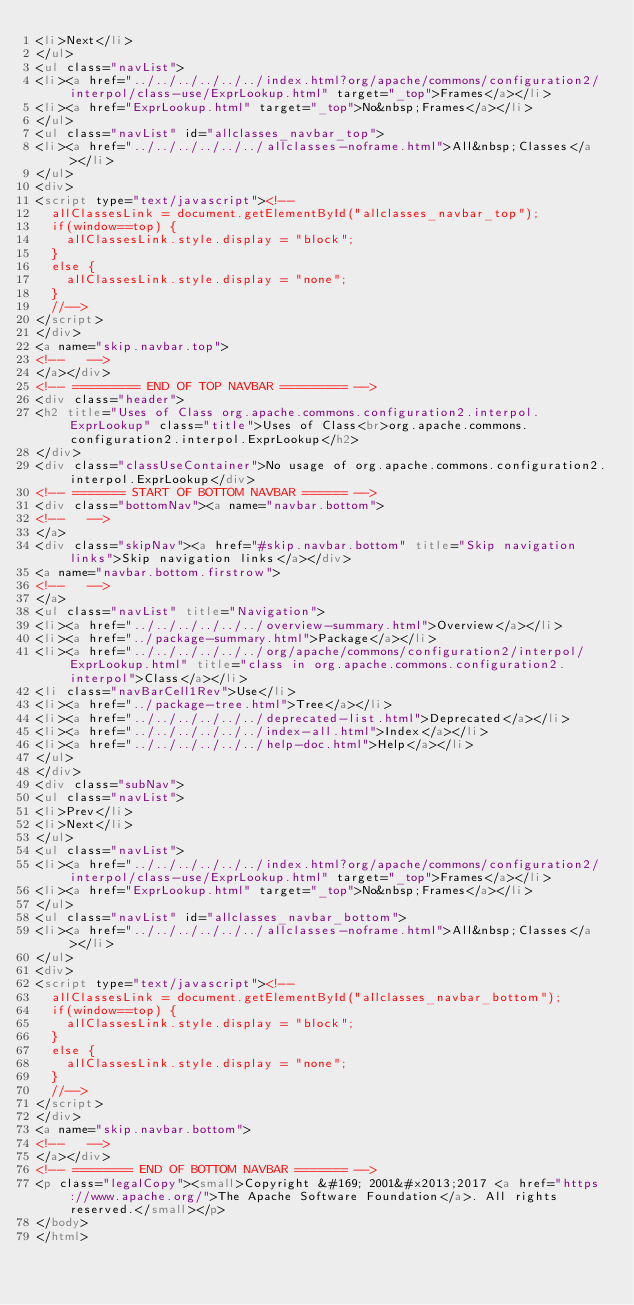Convert code to text. <code><loc_0><loc_0><loc_500><loc_500><_HTML_><li>Next</li>
</ul>
<ul class="navList">
<li><a href="../../../../../../index.html?org/apache/commons/configuration2/interpol/class-use/ExprLookup.html" target="_top">Frames</a></li>
<li><a href="ExprLookup.html" target="_top">No&nbsp;Frames</a></li>
</ul>
<ul class="navList" id="allclasses_navbar_top">
<li><a href="../../../../../../allclasses-noframe.html">All&nbsp;Classes</a></li>
</ul>
<div>
<script type="text/javascript"><!--
  allClassesLink = document.getElementById("allclasses_navbar_top");
  if(window==top) {
    allClassesLink.style.display = "block";
  }
  else {
    allClassesLink.style.display = "none";
  }
  //-->
</script>
</div>
<a name="skip.navbar.top">
<!--   -->
</a></div>
<!-- ========= END OF TOP NAVBAR ========= -->
<div class="header">
<h2 title="Uses of Class org.apache.commons.configuration2.interpol.ExprLookup" class="title">Uses of Class<br>org.apache.commons.configuration2.interpol.ExprLookup</h2>
</div>
<div class="classUseContainer">No usage of org.apache.commons.configuration2.interpol.ExprLookup</div>
<!-- ======= START OF BOTTOM NAVBAR ====== -->
<div class="bottomNav"><a name="navbar.bottom">
<!--   -->
</a>
<div class="skipNav"><a href="#skip.navbar.bottom" title="Skip navigation links">Skip navigation links</a></div>
<a name="navbar.bottom.firstrow">
<!--   -->
</a>
<ul class="navList" title="Navigation">
<li><a href="../../../../../../overview-summary.html">Overview</a></li>
<li><a href="../package-summary.html">Package</a></li>
<li><a href="../../../../../../org/apache/commons/configuration2/interpol/ExprLookup.html" title="class in org.apache.commons.configuration2.interpol">Class</a></li>
<li class="navBarCell1Rev">Use</li>
<li><a href="../package-tree.html">Tree</a></li>
<li><a href="../../../../../../deprecated-list.html">Deprecated</a></li>
<li><a href="../../../../../../index-all.html">Index</a></li>
<li><a href="../../../../../../help-doc.html">Help</a></li>
</ul>
</div>
<div class="subNav">
<ul class="navList">
<li>Prev</li>
<li>Next</li>
</ul>
<ul class="navList">
<li><a href="../../../../../../index.html?org/apache/commons/configuration2/interpol/class-use/ExprLookup.html" target="_top">Frames</a></li>
<li><a href="ExprLookup.html" target="_top">No&nbsp;Frames</a></li>
</ul>
<ul class="navList" id="allclasses_navbar_bottom">
<li><a href="../../../../../../allclasses-noframe.html">All&nbsp;Classes</a></li>
</ul>
<div>
<script type="text/javascript"><!--
  allClassesLink = document.getElementById("allclasses_navbar_bottom");
  if(window==top) {
    allClassesLink.style.display = "block";
  }
  else {
    allClassesLink.style.display = "none";
  }
  //-->
</script>
</div>
<a name="skip.navbar.bottom">
<!--   -->
</a></div>
<!-- ======== END OF BOTTOM NAVBAR ======= -->
<p class="legalCopy"><small>Copyright &#169; 2001&#x2013;2017 <a href="https://www.apache.org/">The Apache Software Foundation</a>. All rights reserved.</small></p>
</body>
</html>
</code> 